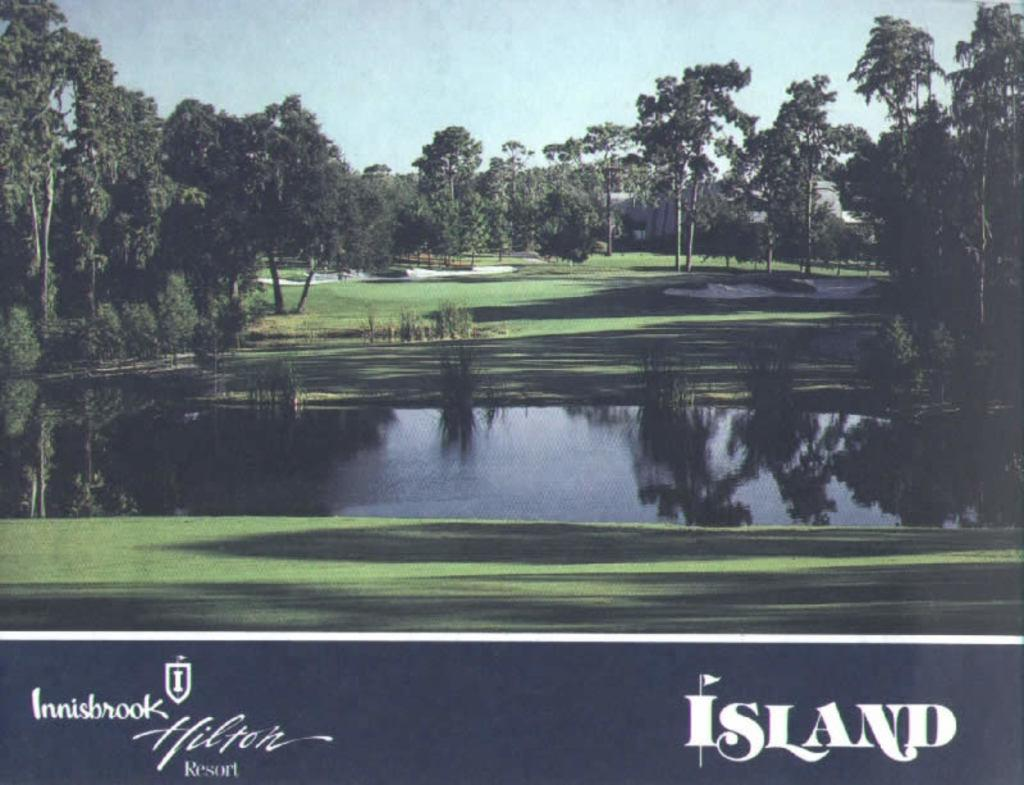What type of natural body of water is present in the image? There is a lake in the image. What type of vegetation can be seen in the image? There is grass and trees in the image. What type of structures are present in the image? There are bunkers in the image. Is there any text present in the image? Yes, there is some text at the bottom of the image. Can you see any wings on the trees in the image? There are no wings present on the trees in the image. What type of coil is wrapped around the bunkers in the image? There is no coil present around the bunkers in the image. 